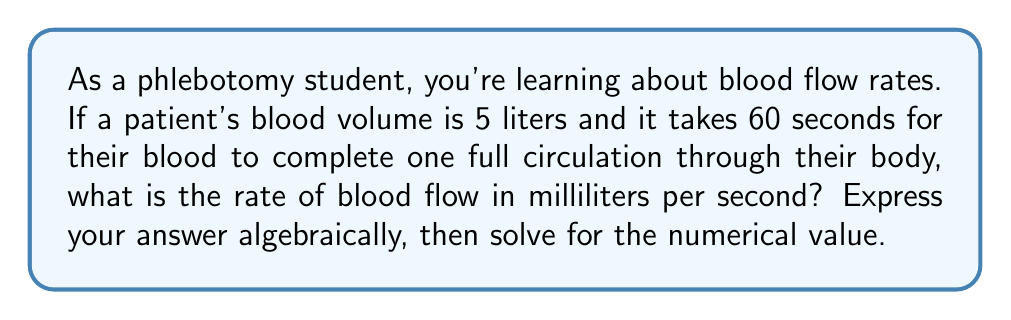Provide a solution to this math problem. Let's approach this step-by-step:

1) First, we need to set up our equation. Let's define our variables:
   $r$ = rate of blood flow (in ml/s)
   $v$ = blood volume (in ml)
   $t$ = time for one full circulation (in s)

2) The basic equation for rate is:
   $$ r = \frac{v}{t} $$

3) We're given the blood volume in liters, but we need it in milliliters:
   $v = 5 \text{ L} = 5000 \text{ ml}$

4) We're given the time in seconds:
   $t = 60 \text{ s}$

5) Now we can substitute these values into our equation:
   $$ r = \frac{5000 \text{ ml}}{60 \text{ s}} $$

6) Simplify:
   $$ r = \frac{5000}{60} \text{ ml/s} = 83.33 \text{ ml/s} $$

7) Rounding to two decimal places:
   $$ r \approx 83.33 \text{ ml/s} $$

This means that approximately 83.33 milliliters of blood flow through the circulatory system each second.
Answer: $r = \frac{5000}{60} \approx 83.33 \text{ ml/s}$ 